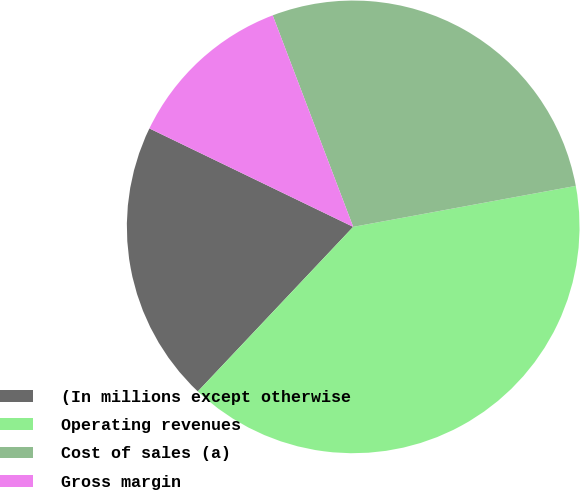Convert chart to OTSL. <chart><loc_0><loc_0><loc_500><loc_500><pie_chart><fcel>(In millions except otherwise<fcel>Operating revenues<fcel>Cost of sales (a)<fcel>Gross margin<nl><fcel>20.12%<fcel>39.94%<fcel>27.89%<fcel>12.05%<nl></chart> 